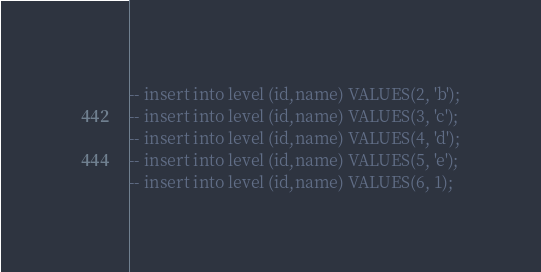Convert code to text. <code><loc_0><loc_0><loc_500><loc_500><_SQL_>-- insert into level (id,name) VALUES(2, 'b');
-- insert into level (id,name) VALUES(3, 'c');
-- insert into level (id,name) VALUES(4, 'd');
-- insert into level (id,name) VALUES(5, 'e');
-- insert into level (id,name) VALUES(6, 1);</code> 